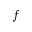Convert formula to latex. <formula><loc_0><loc_0><loc_500><loc_500>f</formula> 